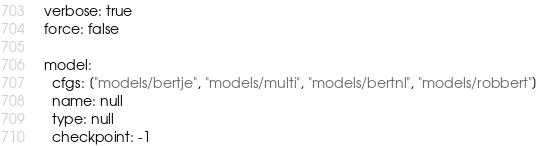<code> <loc_0><loc_0><loc_500><loc_500><_YAML_>verbose: true
force: false

model:
  cfgs: ["models/bertje", "models/multi", "models/bertnl", "models/robbert"]
  name: null
  type: null
  checkpoint: -1</code> 